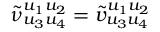Convert formula to latex. <formula><loc_0><loc_0><loc_500><loc_500>\tilde { \nu } _ { u _ { 3 } u _ { 4 } } ^ { u _ { 1 } u _ { 2 } } = \tilde { v } _ { u _ { 3 } u _ { 4 } } ^ { u _ { 1 } u _ { 2 } }</formula> 